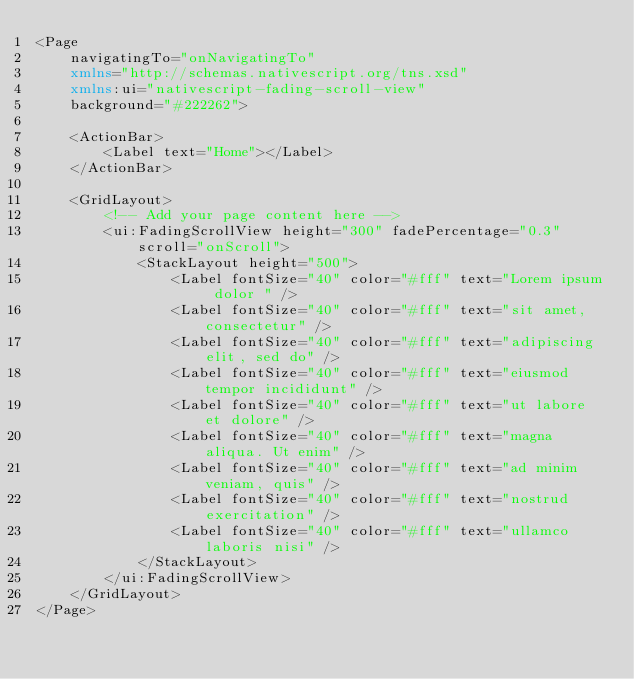Convert code to text. <code><loc_0><loc_0><loc_500><loc_500><_XML_><Page
    navigatingTo="onNavigatingTo"
    xmlns="http://schemas.nativescript.org/tns.xsd"
    xmlns:ui="nativescript-fading-scroll-view"
    background="#222262">

    <ActionBar>
        <Label text="Home"></Label>
    </ActionBar>

    <GridLayout>
        <!-- Add your page content here -->
        <ui:FadingScrollView height="300" fadePercentage="0.3" scroll="onScroll">
            <StackLayout height="500">
                <Label fontSize="40" color="#fff" text="Lorem ipsum dolor " />
                <Label fontSize="40" color="#fff" text="sit amet, consectetur" />
                <Label fontSize="40" color="#fff" text="adipiscing elit, sed do" />
                <Label fontSize="40" color="#fff" text="eiusmod tempor incididunt" />
                <Label fontSize="40" color="#fff" text="ut labore et dolore" />
                <Label fontSize="40" color="#fff" text="magna aliqua. Ut enim" />
                <Label fontSize="40" color="#fff" text="ad minim veniam, quis" />
                <Label fontSize="40" color="#fff" text="nostrud exercitation" />
                <Label fontSize="40" color="#fff" text="ullamco laboris nisi" />
            </StackLayout>
        </ui:FadingScrollView>
    </GridLayout>
</Page>
</code> 